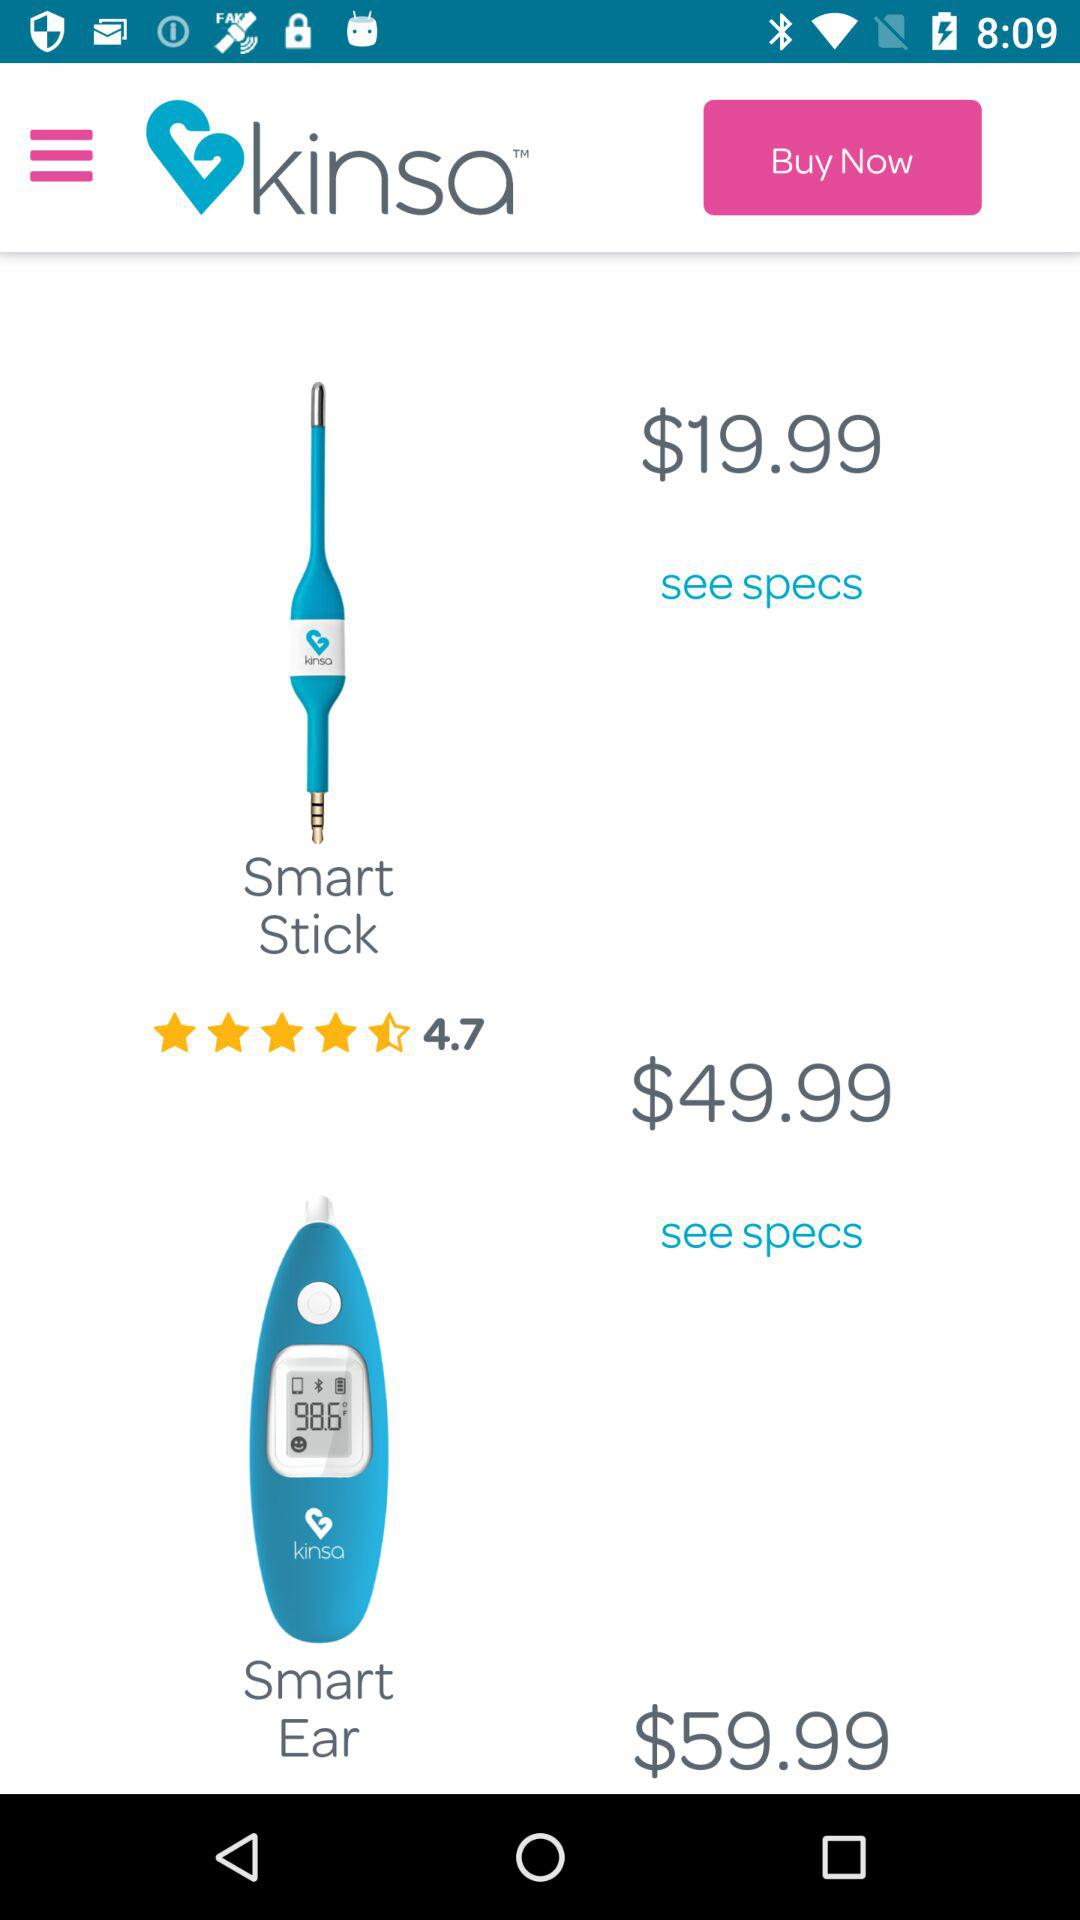What is the price of a smart ear? The price of a smart ear is $49.99. 